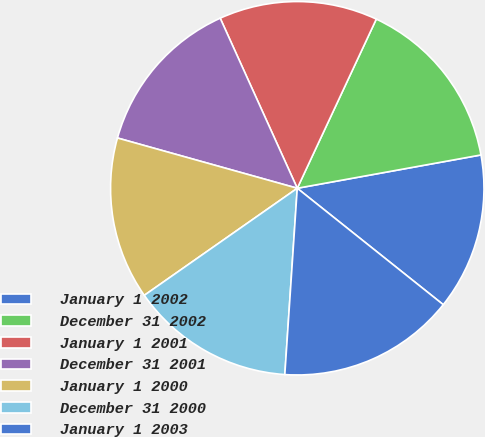Convert chart. <chart><loc_0><loc_0><loc_500><loc_500><pie_chart><fcel>January 1 2002<fcel>December 31 2002<fcel>January 1 2001<fcel>December 31 2001<fcel>January 1 2000<fcel>December 31 2000<fcel>January 1 2003<nl><fcel>13.57%<fcel>15.19%<fcel>13.73%<fcel>13.89%<fcel>14.06%<fcel>14.22%<fcel>15.35%<nl></chart> 